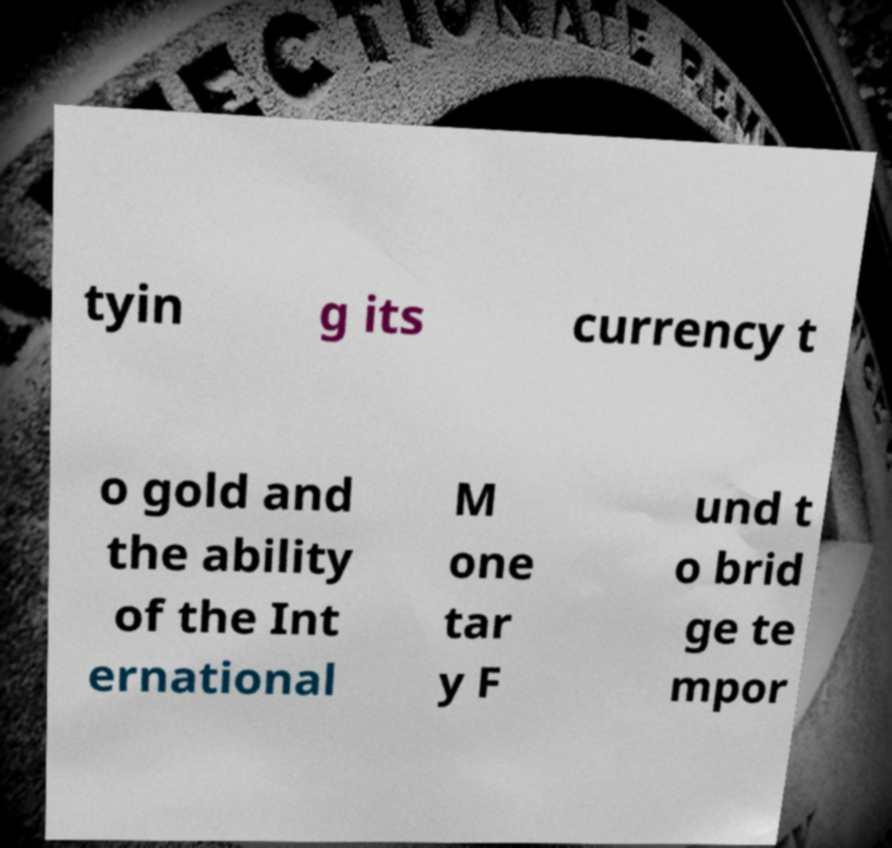I need the written content from this picture converted into text. Can you do that? tyin g its currency t o gold and the ability of the Int ernational M one tar y F und t o brid ge te mpor 